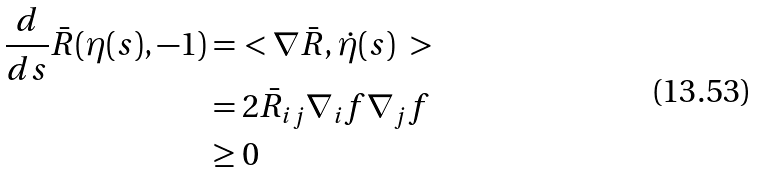Convert formula to latex. <formula><loc_0><loc_0><loc_500><loc_500>\frac { d } { d s } \bar { R } ( \eta ( s ) , - 1 ) & = \ < \nabla \bar { R } , \dot { \eta } ( s ) \ > \\ & = 2 \bar { R } _ { i j } \nabla _ { i } f \nabla _ { j } f \\ & \geq 0</formula> 